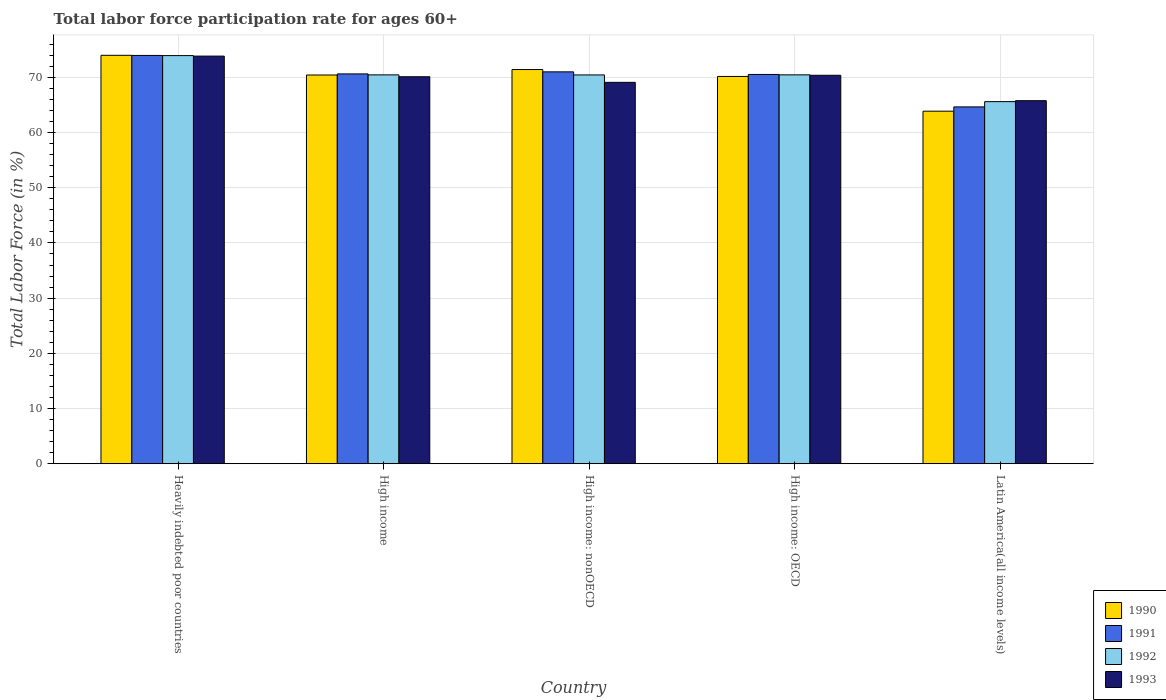How many groups of bars are there?
Provide a succinct answer. 5. What is the label of the 5th group of bars from the left?
Ensure brevity in your answer.  Latin America(all income levels). In how many cases, is the number of bars for a given country not equal to the number of legend labels?
Offer a terse response. 0. What is the labor force participation rate in 1992 in High income: OECD?
Give a very brief answer. 70.44. Across all countries, what is the maximum labor force participation rate in 1992?
Provide a succinct answer. 73.93. Across all countries, what is the minimum labor force participation rate in 1990?
Give a very brief answer. 63.86. In which country was the labor force participation rate in 1990 maximum?
Keep it short and to the point. Heavily indebted poor countries. In which country was the labor force participation rate in 1993 minimum?
Provide a succinct answer. Latin America(all income levels). What is the total labor force participation rate in 1991 in the graph?
Your answer should be very brief. 350.72. What is the difference between the labor force participation rate in 1992 in High income and that in High income: OECD?
Provide a short and direct response. -0. What is the difference between the labor force participation rate in 1990 in Latin America(all income levels) and the labor force participation rate in 1992 in High income: nonOECD?
Give a very brief answer. -6.57. What is the average labor force participation rate in 1991 per country?
Your answer should be very brief. 70.14. What is the difference between the labor force participation rate of/in 1991 and labor force participation rate of/in 1993 in High income: OECD?
Ensure brevity in your answer.  0.15. In how many countries, is the labor force participation rate in 1992 greater than 46 %?
Ensure brevity in your answer.  5. What is the ratio of the labor force participation rate in 1993 in High income to that in High income: OECD?
Your answer should be very brief. 1. Is the difference between the labor force participation rate in 1991 in High income: OECD and Latin America(all income levels) greater than the difference between the labor force participation rate in 1993 in High income: OECD and Latin America(all income levels)?
Your answer should be compact. Yes. What is the difference between the highest and the second highest labor force participation rate in 1992?
Provide a succinct answer. 3.49. What is the difference between the highest and the lowest labor force participation rate in 1992?
Keep it short and to the point. 8.34. Is it the case that in every country, the sum of the labor force participation rate in 1993 and labor force participation rate in 1990 is greater than the sum of labor force participation rate in 1991 and labor force participation rate in 1992?
Offer a terse response. No. How many bars are there?
Offer a terse response. 20. What is the difference between two consecutive major ticks on the Y-axis?
Offer a very short reply. 10. Are the values on the major ticks of Y-axis written in scientific E-notation?
Give a very brief answer. No. Does the graph contain grids?
Give a very brief answer. Yes. Where does the legend appear in the graph?
Ensure brevity in your answer.  Bottom right. How many legend labels are there?
Offer a terse response. 4. What is the title of the graph?
Your answer should be compact. Total labor force participation rate for ages 60+. Does "1994" appear as one of the legend labels in the graph?
Your response must be concise. No. What is the label or title of the X-axis?
Give a very brief answer. Country. What is the Total Labor Force (in %) in 1990 in Heavily indebted poor countries?
Provide a short and direct response. 73.99. What is the Total Labor Force (in %) in 1991 in Heavily indebted poor countries?
Keep it short and to the point. 73.96. What is the Total Labor Force (in %) in 1992 in Heavily indebted poor countries?
Keep it short and to the point. 73.93. What is the Total Labor Force (in %) in 1993 in Heavily indebted poor countries?
Your answer should be very brief. 73.84. What is the Total Labor Force (in %) in 1990 in High income?
Provide a short and direct response. 70.42. What is the Total Labor Force (in %) in 1991 in High income?
Your answer should be very brief. 70.62. What is the Total Labor Force (in %) of 1992 in High income?
Your answer should be compact. 70.44. What is the Total Labor Force (in %) in 1993 in High income?
Ensure brevity in your answer.  70.1. What is the Total Labor Force (in %) of 1990 in High income: nonOECD?
Provide a short and direct response. 71.41. What is the Total Labor Force (in %) in 1991 in High income: nonOECD?
Provide a short and direct response. 70.99. What is the Total Labor Force (in %) in 1992 in High income: nonOECD?
Keep it short and to the point. 70.43. What is the Total Labor Force (in %) of 1993 in High income: nonOECD?
Give a very brief answer. 69.09. What is the Total Labor Force (in %) in 1990 in High income: OECD?
Make the answer very short. 70.16. What is the Total Labor Force (in %) of 1991 in High income: OECD?
Provide a short and direct response. 70.52. What is the Total Labor Force (in %) in 1992 in High income: OECD?
Ensure brevity in your answer.  70.44. What is the Total Labor Force (in %) in 1993 in High income: OECD?
Offer a very short reply. 70.37. What is the Total Labor Force (in %) in 1990 in Latin America(all income levels)?
Give a very brief answer. 63.86. What is the Total Labor Force (in %) of 1991 in Latin America(all income levels)?
Provide a succinct answer. 64.64. What is the Total Labor Force (in %) of 1992 in Latin America(all income levels)?
Keep it short and to the point. 65.59. What is the Total Labor Force (in %) in 1993 in Latin America(all income levels)?
Ensure brevity in your answer.  65.77. Across all countries, what is the maximum Total Labor Force (in %) in 1990?
Give a very brief answer. 73.99. Across all countries, what is the maximum Total Labor Force (in %) of 1991?
Your answer should be very brief. 73.96. Across all countries, what is the maximum Total Labor Force (in %) in 1992?
Give a very brief answer. 73.93. Across all countries, what is the maximum Total Labor Force (in %) in 1993?
Keep it short and to the point. 73.84. Across all countries, what is the minimum Total Labor Force (in %) in 1990?
Provide a succinct answer. 63.86. Across all countries, what is the minimum Total Labor Force (in %) of 1991?
Your answer should be very brief. 64.64. Across all countries, what is the minimum Total Labor Force (in %) of 1992?
Give a very brief answer. 65.59. Across all countries, what is the minimum Total Labor Force (in %) in 1993?
Offer a terse response. 65.77. What is the total Total Labor Force (in %) of 1990 in the graph?
Your answer should be very brief. 349.83. What is the total Total Labor Force (in %) of 1991 in the graph?
Make the answer very short. 350.72. What is the total Total Labor Force (in %) in 1992 in the graph?
Provide a short and direct response. 350.85. What is the total Total Labor Force (in %) of 1993 in the graph?
Your response must be concise. 349.16. What is the difference between the Total Labor Force (in %) in 1990 in Heavily indebted poor countries and that in High income?
Provide a short and direct response. 3.57. What is the difference between the Total Labor Force (in %) of 1991 in Heavily indebted poor countries and that in High income?
Your response must be concise. 3.34. What is the difference between the Total Labor Force (in %) of 1992 in Heavily indebted poor countries and that in High income?
Your response must be concise. 3.49. What is the difference between the Total Labor Force (in %) in 1993 in Heavily indebted poor countries and that in High income?
Provide a short and direct response. 3.74. What is the difference between the Total Labor Force (in %) of 1990 in Heavily indebted poor countries and that in High income: nonOECD?
Offer a terse response. 2.58. What is the difference between the Total Labor Force (in %) of 1991 in Heavily indebted poor countries and that in High income: nonOECD?
Your answer should be compact. 2.97. What is the difference between the Total Labor Force (in %) of 1992 in Heavily indebted poor countries and that in High income: nonOECD?
Offer a terse response. 3.5. What is the difference between the Total Labor Force (in %) in 1993 in Heavily indebted poor countries and that in High income: nonOECD?
Your response must be concise. 4.76. What is the difference between the Total Labor Force (in %) of 1990 in Heavily indebted poor countries and that in High income: OECD?
Give a very brief answer. 3.83. What is the difference between the Total Labor Force (in %) in 1991 in Heavily indebted poor countries and that in High income: OECD?
Offer a terse response. 3.44. What is the difference between the Total Labor Force (in %) in 1992 in Heavily indebted poor countries and that in High income: OECD?
Give a very brief answer. 3.49. What is the difference between the Total Labor Force (in %) of 1993 in Heavily indebted poor countries and that in High income: OECD?
Offer a terse response. 3.47. What is the difference between the Total Labor Force (in %) of 1990 in Heavily indebted poor countries and that in Latin America(all income levels)?
Ensure brevity in your answer.  10.12. What is the difference between the Total Labor Force (in %) of 1991 in Heavily indebted poor countries and that in Latin America(all income levels)?
Provide a succinct answer. 9.32. What is the difference between the Total Labor Force (in %) of 1992 in Heavily indebted poor countries and that in Latin America(all income levels)?
Your response must be concise. 8.34. What is the difference between the Total Labor Force (in %) in 1993 in Heavily indebted poor countries and that in Latin America(all income levels)?
Provide a short and direct response. 8.08. What is the difference between the Total Labor Force (in %) in 1990 in High income and that in High income: nonOECD?
Your response must be concise. -0.99. What is the difference between the Total Labor Force (in %) of 1991 in High income and that in High income: nonOECD?
Make the answer very short. -0.37. What is the difference between the Total Labor Force (in %) of 1992 in High income and that in High income: nonOECD?
Ensure brevity in your answer.  0.01. What is the difference between the Total Labor Force (in %) in 1993 in High income and that in High income: nonOECD?
Offer a very short reply. 1.02. What is the difference between the Total Labor Force (in %) in 1990 in High income and that in High income: OECD?
Give a very brief answer. 0.26. What is the difference between the Total Labor Force (in %) of 1991 in High income and that in High income: OECD?
Offer a terse response. 0.1. What is the difference between the Total Labor Force (in %) in 1992 in High income and that in High income: OECD?
Offer a very short reply. -0. What is the difference between the Total Labor Force (in %) in 1993 in High income and that in High income: OECD?
Ensure brevity in your answer.  -0.27. What is the difference between the Total Labor Force (in %) in 1990 in High income and that in Latin America(all income levels)?
Ensure brevity in your answer.  6.55. What is the difference between the Total Labor Force (in %) in 1991 in High income and that in Latin America(all income levels)?
Give a very brief answer. 5.98. What is the difference between the Total Labor Force (in %) of 1992 in High income and that in Latin America(all income levels)?
Offer a very short reply. 4.85. What is the difference between the Total Labor Force (in %) of 1993 in High income and that in Latin America(all income levels)?
Keep it short and to the point. 4.34. What is the difference between the Total Labor Force (in %) in 1990 in High income: nonOECD and that in High income: OECD?
Your response must be concise. 1.25. What is the difference between the Total Labor Force (in %) of 1991 in High income: nonOECD and that in High income: OECD?
Ensure brevity in your answer.  0.47. What is the difference between the Total Labor Force (in %) of 1992 in High income: nonOECD and that in High income: OECD?
Keep it short and to the point. -0.01. What is the difference between the Total Labor Force (in %) in 1993 in High income: nonOECD and that in High income: OECD?
Offer a terse response. -1.28. What is the difference between the Total Labor Force (in %) in 1990 in High income: nonOECD and that in Latin America(all income levels)?
Make the answer very short. 7.54. What is the difference between the Total Labor Force (in %) of 1991 in High income: nonOECD and that in Latin America(all income levels)?
Your answer should be very brief. 6.35. What is the difference between the Total Labor Force (in %) of 1992 in High income: nonOECD and that in Latin America(all income levels)?
Provide a short and direct response. 4.84. What is the difference between the Total Labor Force (in %) in 1993 in High income: nonOECD and that in Latin America(all income levels)?
Make the answer very short. 3.32. What is the difference between the Total Labor Force (in %) of 1990 in High income: OECD and that in Latin America(all income levels)?
Give a very brief answer. 6.29. What is the difference between the Total Labor Force (in %) in 1991 in High income: OECD and that in Latin America(all income levels)?
Give a very brief answer. 5.88. What is the difference between the Total Labor Force (in %) of 1992 in High income: OECD and that in Latin America(all income levels)?
Make the answer very short. 4.85. What is the difference between the Total Labor Force (in %) in 1993 in High income: OECD and that in Latin America(all income levels)?
Ensure brevity in your answer.  4.6. What is the difference between the Total Labor Force (in %) in 1990 in Heavily indebted poor countries and the Total Labor Force (in %) in 1991 in High income?
Give a very brief answer. 3.37. What is the difference between the Total Labor Force (in %) in 1990 in Heavily indebted poor countries and the Total Labor Force (in %) in 1992 in High income?
Make the answer very short. 3.55. What is the difference between the Total Labor Force (in %) of 1990 in Heavily indebted poor countries and the Total Labor Force (in %) of 1993 in High income?
Keep it short and to the point. 3.88. What is the difference between the Total Labor Force (in %) of 1991 in Heavily indebted poor countries and the Total Labor Force (in %) of 1992 in High income?
Give a very brief answer. 3.52. What is the difference between the Total Labor Force (in %) of 1991 in Heavily indebted poor countries and the Total Labor Force (in %) of 1993 in High income?
Your answer should be very brief. 3.86. What is the difference between the Total Labor Force (in %) in 1992 in Heavily indebted poor countries and the Total Labor Force (in %) in 1993 in High income?
Give a very brief answer. 3.83. What is the difference between the Total Labor Force (in %) of 1990 in Heavily indebted poor countries and the Total Labor Force (in %) of 1991 in High income: nonOECD?
Ensure brevity in your answer.  3. What is the difference between the Total Labor Force (in %) of 1990 in Heavily indebted poor countries and the Total Labor Force (in %) of 1992 in High income: nonOECD?
Provide a short and direct response. 3.56. What is the difference between the Total Labor Force (in %) of 1990 in Heavily indebted poor countries and the Total Labor Force (in %) of 1993 in High income: nonOECD?
Your answer should be very brief. 4.9. What is the difference between the Total Labor Force (in %) in 1991 in Heavily indebted poor countries and the Total Labor Force (in %) in 1992 in High income: nonOECD?
Offer a terse response. 3.53. What is the difference between the Total Labor Force (in %) in 1991 in Heavily indebted poor countries and the Total Labor Force (in %) in 1993 in High income: nonOECD?
Offer a very short reply. 4.87. What is the difference between the Total Labor Force (in %) of 1992 in Heavily indebted poor countries and the Total Labor Force (in %) of 1993 in High income: nonOECD?
Offer a terse response. 4.85. What is the difference between the Total Labor Force (in %) of 1990 in Heavily indebted poor countries and the Total Labor Force (in %) of 1991 in High income: OECD?
Keep it short and to the point. 3.47. What is the difference between the Total Labor Force (in %) in 1990 in Heavily indebted poor countries and the Total Labor Force (in %) in 1992 in High income: OECD?
Your answer should be very brief. 3.54. What is the difference between the Total Labor Force (in %) in 1990 in Heavily indebted poor countries and the Total Labor Force (in %) in 1993 in High income: OECD?
Make the answer very short. 3.62. What is the difference between the Total Labor Force (in %) in 1991 in Heavily indebted poor countries and the Total Labor Force (in %) in 1992 in High income: OECD?
Keep it short and to the point. 3.51. What is the difference between the Total Labor Force (in %) in 1991 in Heavily indebted poor countries and the Total Labor Force (in %) in 1993 in High income: OECD?
Offer a very short reply. 3.59. What is the difference between the Total Labor Force (in %) in 1992 in Heavily indebted poor countries and the Total Labor Force (in %) in 1993 in High income: OECD?
Give a very brief answer. 3.57. What is the difference between the Total Labor Force (in %) in 1990 in Heavily indebted poor countries and the Total Labor Force (in %) in 1991 in Latin America(all income levels)?
Make the answer very short. 9.35. What is the difference between the Total Labor Force (in %) of 1990 in Heavily indebted poor countries and the Total Labor Force (in %) of 1992 in Latin America(all income levels)?
Provide a short and direct response. 8.39. What is the difference between the Total Labor Force (in %) in 1990 in Heavily indebted poor countries and the Total Labor Force (in %) in 1993 in Latin America(all income levels)?
Your response must be concise. 8.22. What is the difference between the Total Labor Force (in %) of 1991 in Heavily indebted poor countries and the Total Labor Force (in %) of 1992 in Latin America(all income levels)?
Your response must be concise. 8.37. What is the difference between the Total Labor Force (in %) of 1991 in Heavily indebted poor countries and the Total Labor Force (in %) of 1993 in Latin America(all income levels)?
Make the answer very short. 8.19. What is the difference between the Total Labor Force (in %) in 1992 in Heavily indebted poor countries and the Total Labor Force (in %) in 1993 in Latin America(all income levels)?
Your answer should be very brief. 8.17. What is the difference between the Total Labor Force (in %) in 1990 in High income and the Total Labor Force (in %) in 1991 in High income: nonOECD?
Give a very brief answer. -0.57. What is the difference between the Total Labor Force (in %) of 1990 in High income and the Total Labor Force (in %) of 1992 in High income: nonOECD?
Ensure brevity in your answer.  -0.01. What is the difference between the Total Labor Force (in %) in 1990 in High income and the Total Labor Force (in %) in 1993 in High income: nonOECD?
Provide a succinct answer. 1.33. What is the difference between the Total Labor Force (in %) in 1991 in High income and the Total Labor Force (in %) in 1992 in High income: nonOECD?
Make the answer very short. 0.18. What is the difference between the Total Labor Force (in %) in 1991 in High income and the Total Labor Force (in %) in 1993 in High income: nonOECD?
Keep it short and to the point. 1.53. What is the difference between the Total Labor Force (in %) in 1992 in High income and the Total Labor Force (in %) in 1993 in High income: nonOECD?
Offer a very short reply. 1.36. What is the difference between the Total Labor Force (in %) of 1990 in High income and the Total Labor Force (in %) of 1991 in High income: OECD?
Keep it short and to the point. -0.1. What is the difference between the Total Labor Force (in %) in 1990 in High income and the Total Labor Force (in %) in 1992 in High income: OECD?
Give a very brief answer. -0.03. What is the difference between the Total Labor Force (in %) of 1991 in High income and the Total Labor Force (in %) of 1992 in High income: OECD?
Your answer should be very brief. 0.17. What is the difference between the Total Labor Force (in %) in 1991 in High income and the Total Labor Force (in %) in 1993 in High income: OECD?
Provide a short and direct response. 0.25. What is the difference between the Total Labor Force (in %) of 1992 in High income and the Total Labor Force (in %) of 1993 in High income: OECD?
Make the answer very short. 0.07. What is the difference between the Total Labor Force (in %) in 1990 in High income and the Total Labor Force (in %) in 1991 in Latin America(all income levels)?
Give a very brief answer. 5.78. What is the difference between the Total Labor Force (in %) of 1990 in High income and the Total Labor Force (in %) of 1992 in Latin America(all income levels)?
Provide a short and direct response. 4.82. What is the difference between the Total Labor Force (in %) in 1990 in High income and the Total Labor Force (in %) in 1993 in Latin America(all income levels)?
Provide a succinct answer. 4.65. What is the difference between the Total Labor Force (in %) in 1991 in High income and the Total Labor Force (in %) in 1992 in Latin America(all income levels)?
Ensure brevity in your answer.  5.02. What is the difference between the Total Labor Force (in %) in 1991 in High income and the Total Labor Force (in %) in 1993 in Latin America(all income levels)?
Offer a very short reply. 4.85. What is the difference between the Total Labor Force (in %) in 1992 in High income and the Total Labor Force (in %) in 1993 in Latin America(all income levels)?
Keep it short and to the point. 4.68. What is the difference between the Total Labor Force (in %) in 1990 in High income: nonOECD and the Total Labor Force (in %) in 1991 in High income: OECD?
Keep it short and to the point. 0.89. What is the difference between the Total Labor Force (in %) in 1990 in High income: nonOECD and the Total Labor Force (in %) in 1993 in High income: OECD?
Offer a very short reply. 1.04. What is the difference between the Total Labor Force (in %) in 1991 in High income: nonOECD and the Total Labor Force (in %) in 1992 in High income: OECD?
Make the answer very short. 0.54. What is the difference between the Total Labor Force (in %) of 1991 in High income: nonOECD and the Total Labor Force (in %) of 1993 in High income: OECD?
Your response must be concise. 0.62. What is the difference between the Total Labor Force (in %) in 1992 in High income: nonOECD and the Total Labor Force (in %) in 1993 in High income: OECD?
Offer a very short reply. 0.06. What is the difference between the Total Labor Force (in %) in 1990 in High income: nonOECD and the Total Labor Force (in %) in 1991 in Latin America(all income levels)?
Offer a terse response. 6.77. What is the difference between the Total Labor Force (in %) in 1990 in High income: nonOECD and the Total Labor Force (in %) in 1992 in Latin America(all income levels)?
Your answer should be very brief. 5.81. What is the difference between the Total Labor Force (in %) of 1990 in High income: nonOECD and the Total Labor Force (in %) of 1993 in Latin America(all income levels)?
Provide a short and direct response. 5.64. What is the difference between the Total Labor Force (in %) in 1991 in High income: nonOECD and the Total Labor Force (in %) in 1992 in Latin America(all income levels)?
Keep it short and to the point. 5.4. What is the difference between the Total Labor Force (in %) of 1991 in High income: nonOECD and the Total Labor Force (in %) of 1993 in Latin America(all income levels)?
Offer a very short reply. 5.22. What is the difference between the Total Labor Force (in %) in 1992 in High income: nonOECD and the Total Labor Force (in %) in 1993 in Latin America(all income levels)?
Provide a short and direct response. 4.67. What is the difference between the Total Labor Force (in %) in 1990 in High income: OECD and the Total Labor Force (in %) in 1991 in Latin America(all income levels)?
Your answer should be very brief. 5.51. What is the difference between the Total Labor Force (in %) of 1990 in High income: OECD and the Total Labor Force (in %) of 1992 in Latin America(all income levels)?
Ensure brevity in your answer.  4.56. What is the difference between the Total Labor Force (in %) of 1990 in High income: OECD and the Total Labor Force (in %) of 1993 in Latin America(all income levels)?
Your answer should be very brief. 4.39. What is the difference between the Total Labor Force (in %) in 1991 in High income: OECD and the Total Labor Force (in %) in 1992 in Latin America(all income levels)?
Your answer should be very brief. 4.92. What is the difference between the Total Labor Force (in %) of 1991 in High income: OECD and the Total Labor Force (in %) of 1993 in Latin America(all income levels)?
Provide a short and direct response. 4.75. What is the difference between the Total Labor Force (in %) of 1992 in High income: OECD and the Total Labor Force (in %) of 1993 in Latin America(all income levels)?
Give a very brief answer. 4.68. What is the average Total Labor Force (in %) of 1990 per country?
Offer a terse response. 69.97. What is the average Total Labor Force (in %) in 1991 per country?
Keep it short and to the point. 70.14. What is the average Total Labor Force (in %) in 1992 per country?
Offer a terse response. 70.17. What is the average Total Labor Force (in %) in 1993 per country?
Your answer should be very brief. 69.83. What is the difference between the Total Labor Force (in %) in 1990 and Total Labor Force (in %) in 1991 in Heavily indebted poor countries?
Offer a very short reply. 0.03. What is the difference between the Total Labor Force (in %) in 1990 and Total Labor Force (in %) in 1992 in Heavily indebted poor countries?
Your answer should be very brief. 0.05. What is the difference between the Total Labor Force (in %) of 1990 and Total Labor Force (in %) of 1993 in Heavily indebted poor countries?
Provide a succinct answer. 0.15. What is the difference between the Total Labor Force (in %) in 1991 and Total Labor Force (in %) in 1992 in Heavily indebted poor countries?
Keep it short and to the point. 0.03. What is the difference between the Total Labor Force (in %) in 1991 and Total Labor Force (in %) in 1993 in Heavily indebted poor countries?
Provide a succinct answer. 0.12. What is the difference between the Total Labor Force (in %) in 1992 and Total Labor Force (in %) in 1993 in Heavily indebted poor countries?
Ensure brevity in your answer.  0.09. What is the difference between the Total Labor Force (in %) of 1990 and Total Labor Force (in %) of 1991 in High income?
Provide a succinct answer. -0.2. What is the difference between the Total Labor Force (in %) of 1990 and Total Labor Force (in %) of 1992 in High income?
Provide a succinct answer. -0.02. What is the difference between the Total Labor Force (in %) in 1990 and Total Labor Force (in %) in 1993 in High income?
Your response must be concise. 0.32. What is the difference between the Total Labor Force (in %) in 1991 and Total Labor Force (in %) in 1992 in High income?
Offer a very short reply. 0.17. What is the difference between the Total Labor Force (in %) of 1991 and Total Labor Force (in %) of 1993 in High income?
Give a very brief answer. 0.51. What is the difference between the Total Labor Force (in %) of 1992 and Total Labor Force (in %) of 1993 in High income?
Your answer should be very brief. 0.34. What is the difference between the Total Labor Force (in %) of 1990 and Total Labor Force (in %) of 1991 in High income: nonOECD?
Your response must be concise. 0.42. What is the difference between the Total Labor Force (in %) of 1990 and Total Labor Force (in %) of 1992 in High income: nonOECD?
Offer a very short reply. 0.98. What is the difference between the Total Labor Force (in %) of 1990 and Total Labor Force (in %) of 1993 in High income: nonOECD?
Make the answer very short. 2.32. What is the difference between the Total Labor Force (in %) in 1991 and Total Labor Force (in %) in 1992 in High income: nonOECD?
Your answer should be compact. 0.56. What is the difference between the Total Labor Force (in %) of 1991 and Total Labor Force (in %) of 1993 in High income: nonOECD?
Offer a very short reply. 1.9. What is the difference between the Total Labor Force (in %) of 1992 and Total Labor Force (in %) of 1993 in High income: nonOECD?
Ensure brevity in your answer.  1.35. What is the difference between the Total Labor Force (in %) of 1990 and Total Labor Force (in %) of 1991 in High income: OECD?
Offer a very short reply. -0.36. What is the difference between the Total Labor Force (in %) in 1990 and Total Labor Force (in %) in 1992 in High income: OECD?
Keep it short and to the point. -0.29. What is the difference between the Total Labor Force (in %) in 1990 and Total Labor Force (in %) in 1993 in High income: OECD?
Make the answer very short. -0.21. What is the difference between the Total Labor Force (in %) of 1991 and Total Labor Force (in %) of 1992 in High income: OECD?
Make the answer very short. 0.07. What is the difference between the Total Labor Force (in %) of 1991 and Total Labor Force (in %) of 1993 in High income: OECD?
Offer a terse response. 0.15. What is the difference between the Total Labor Force (in %) of 1992 and Total Labor Force (in %) of 1993 in High income: OECD?
Ensure brevity in your answer.  0.08. What is the difference between the Total Labor Force (in %) in 1990 and Total Labor Force (in %) in 1991 in Latin America(all income levels)?
Make the answer very short. -0.78. What is the difference between the Total Labor Force (in %) of 1990 and Total Labor Force (in %) of 1992 in Latin America(all income levels)?
Your response must be concise. -1.73. What is the difference between the Total Labor Force (in %) in 1990 and Total Labor Force (in %) in 1993 in Latin America(all income levels)?
Your response must be concise. -1.9. What is the difference between the Total Labor Force (in %) of 1991 and Total Labor Force (in %) of 1992 in Latin America(all income levels)?
Offer a terse response. -0.95. What is the difference between the Total Labor Force (in %) of 1991 and Total Labor Force (in %) of 1993 in Latin America(all income levels)?
Make the answer very short. -1.12. What is the difference between the Total Labor Force (in %) of 1992 and Total Labor Force (in %) of 1993 in Latin America(all income levels)?
Ensure brevity in your answer.  -0.17. What is the ratio of the Total Labor Force (in %) in 1990 in Heavily indebted poor countries to that in High income?
Offer a very short reply. 1.05. What is the ratio of the Total Labor Force (in %) in 1991 in Heavily indebted poor countries to that in High income?
Offer a very short reply. 1.05. What is the ratio of the Total Labor Force (in %) in 1992 in Heavily indebted poor countries to that in High income?
Offer a terse response. 1.05. What is the ratio of the Total Labor Force (in %) in 1993 in Heavily indebted poor countries to that in High income?
Keep it short and to the point. 1.05. What is the ratio of the Total Labor Force (in %) of 1990 in Heavily indebted poor countries to that in High income: nonOECD?
Keep it short and to the point. 1.04. What is the ratio of the Total Labor Force (in %) of 1991 in Heavily indebted poor countries to that in High income: nonOECD?
Provide a succinct answer. 1.04. What is the ratio of the Total Labor Force (in %) in 1992 in Heavily indebted poor countries to that in High income: nonOECD?
Give a very brief answer. 1.05. What is the ratio of the Total Labor Force (in %) of 1993 in Heavily indebted poor countries to that in High income: nonOECD?
Provide a short and direct response. 1.07. What is the ratio of the Total Labor Force (in %) in 1990 in Heavily indebted poor countries to that in High income: OECD?
Provide a succinct answer. 1.05. What is the ratio of the Total Labor Force (in %) in 1991 in Heavily indebted poor countries to that in High income: OECD?
Your response must be concise. 1.05. What is the ratio of the Total Labor Force (in %) in 1992 in Heavily indebted poor countries to that in High income: OECD?
Provide a short and direct response. 1.05. What is the ratio of the Total Labor Force (in %) of 1993 in Heavily indebted poor countries to that in High income: OECD?
Your answer should be compact. 1.05. What is the ratio of the Total Labor Force (in %) in 1990 in Heavily indebted poor countries to that in Latin America(all income levels)?
Ensure brevity in your answer.  1.16. What is the ratio of the Total Labor Force (in %) in 1991 in Heavily indebted poor countries to that in Latin America(all income levels)?
Provide a succinct answer. 1.14. What is the ratio of the Total Labor Force (in %) in 1992 in Heavily indebted poor countries to that in Latin America(all income levels)?
Make the answer very short. 1.13. What is the ratio of the Total Labor Force (in %) in 1993 in Heavily indebted poor countries to that in Latin America(all income levels)?
Offer a very short reply. 1.12. What is the ratio of the Total Labor Force (in %) of 1990 in High income to that in High income: nonOECD?
Provide a succinct answer. 0.99. What is the ratio of the Total Labor Force (in %) in 1991 in High income to that in High income: nonOECD?
Your answer should be very brief. 0.99. What is the ratio of the Total Labor Force (in %) in 1993 in High income to that in High income: nonOECD?
Your response must be concise. 1.01. What is the ratio of the Total Labor Force (in %) of 1990 in High income to that in Latin America(all income levels)?
Make the answer very short. 1.1. What is the ratio of the Total Labor Force (in %) in 1991 in High income to that in Latin America(all income levels)?
Provide a succinct answer. 1.09. What is the ratio of the Total Labor Force (in %) in 1992 in High income to that in Latin America(all income levels)?
Offer a terse response. 1.07. What is the ratio of the Total Labor Force (in %) of 1993 in High income to that in Latin America(all income levels)?
Offer a very short reply. 1.07. What is the ratio of the Total Labor Force (in %) in 1990 in High income: nonOECD to that in High income: OECD?
Your answer should be very brief. 1.02. What is the ratio of the Total Labor Force (in %) of 1992 in High income: nonOECD to that in High income: OECD?
Offer a very short reply. 1. What is the ratio of the Total Labor Force (in %) in 1993 in High income: nonOECD to that in High income: OECD?
Offer a very short reply. 0.98. What is the ratio of the Total Labor Force (in %) in 1990 in High income: nonOECD to that in Latin America(all income levels)?
Give a very brief answer. 1.12. What is the ratio of the Total Labor Force (in %) of 1991 in High income: nonOECD to that in Latin America(all income levels)?
Give a very brief answer. 1.1. What is the ratio of the Total Labor Force (in %) of 1992 in High income: nonOECD to that in Latin America(all income levels)?
Provide a short and direct response. 1.07. What is the ratio of the Total Labor Force (in %) of 1993 in High income: nonOECD to that in Latin America(all income levels)?
Offer a very short reply. 1.05. What is the ratio of the Total Labor Force (in %) of 1990 in High income: OECD to that in Latin America(all income levels)?
Provide a succinct answer. 1.1. What is the ratio of the Total Labor Force (in %) in 1992 in High income: OECD to that in Latin America(all income levels)?
Your response must be concise. 1.07. What is the ratio of the Total Labor Force (in %) in 1993 in High income: OECD to that in Latin America(all income levels)?
Keep it short and to the point. 1.07. What is the difference between the highest and the second highest Total Labor Force (in %) of 1990?
Ensure brevity in your answer.  2.58. What is the difference between the highest and the second highest Total Labor Force (in %) in 1991?
Your response must be concise. 2.97. What is the difference between the highest and the second highest Total Labor Force (in %) of 1992?
Your answer should be very brief. 3.49. What is the difference between the highest and the second highest Total Labor Force (in %) of 1993?
Ensure brevity in your answer.  3.47. What is the difference between the highest and the lowest Total Labor Force (in %) of 1990?
Your response must be concise. 10.12. What is the difference between the highest and the lowest Total Labor Force (in %) in 1991?
Offer a very short reply. 9.32. What is the difference between the highest and the lowest Total Labor Force (in %) of 1992?
Provide a succinct answer. 8.34. What is the difference between the highest and the lowest Total Labor Force (in %) in 1993?
Your response must be concise. 8.08. 